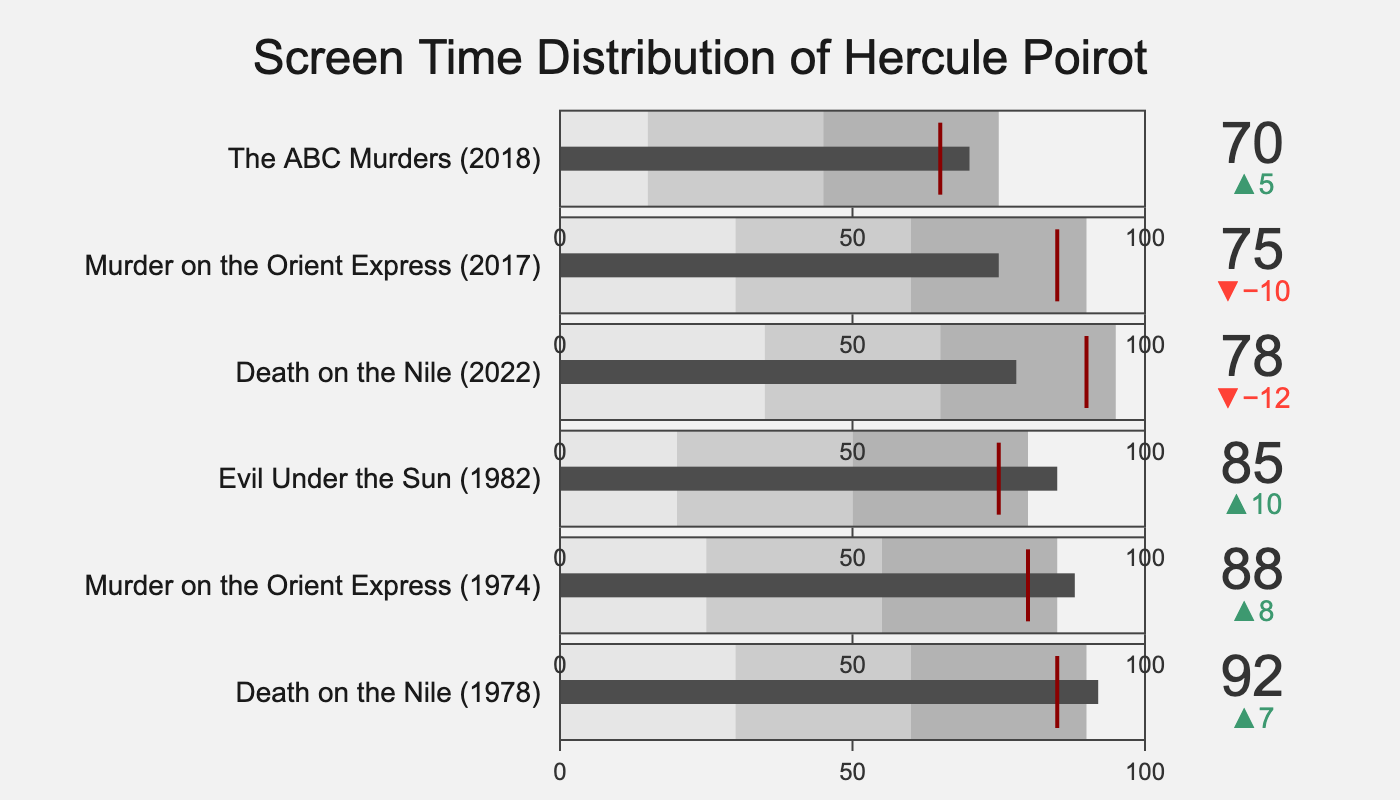What is the title of the chart? The title is located at the top center of the chart, providing an overview of what the chart is about.
Answer: Screen Time Distribution of Hercule Poirot Which film adaptation has the highest actual screen time for Hercule Poirot? Look at the value bars and identify the bar with the highest value.
Answer: Death on the Nile (1978) How does the actual screen time in Death on the Nile (2022) compare to its comparative screen time? Determine the actual and comparative values from the bullet chart and compare them.
Answer: The actual screen time is 78, which is less than the comparative screen time of 90 Which two film adaptations have an actual screen time of exactly 75? Look at the actual screen time values on the bars and note which film adaptations have 75.
Answer: Murder on the Orient Express (2017) and Evil Under the Sun (1982) What is the difference in actual screen time between the film adaptation with the highest and lowest values? Identify the highest and lowest actual values and subtract the lowest from the highest.
Answer: 92 (Death on the Nile 1978) - 70 (The ABC Murders 2018) = 22 Which film adaptations have an actual screen time that falls within their middle range? Compare actual screen time values with their respective middle ranges.
Answer: Death on the Nile (1978), Murder on the Orient Express (1974), Evil Under the Sun (1982), and Death on the Nile (2022) What's the average actual screen time across all six film adaptations? Sum all the actual screen times and divide by the number of film adaptations (6).
Answer: (92 + 88 + 85 + 78 + 75 + 70) / 6 = 81.33 Which film adaptation has the smallest gap between its actual and comparative screen time? Calculate the differences between actual and comparative screen times and identify the smallest.
Answer: The ABC Murders (2018) with a gap of 5 (70 - 65) How many film adaptations have comparative screen times more than 80? Count the comparative screen times that exceed 80.
Answer: Four (Death on the Nile 1978, Murder on the Orient Express 1974, Death on the Nile 2022, Murder on the Orient Express 2017) What is common in the gauge coloring for all film adaptations? Examine the gauge steps' colors used for each adaptation within the bullet chart.
Answer: They all share the same color scheme with three shades of gray for the ranges 